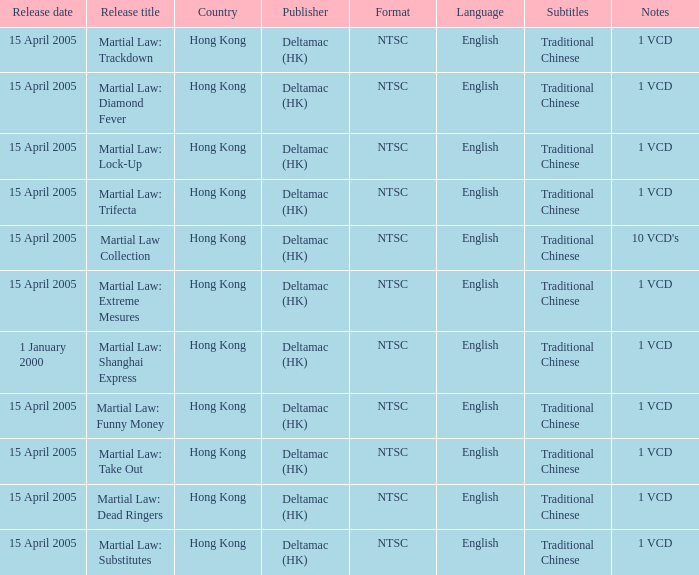Where was the 1 vcd called "martial law: substitutes" made available? Hong Kong. 